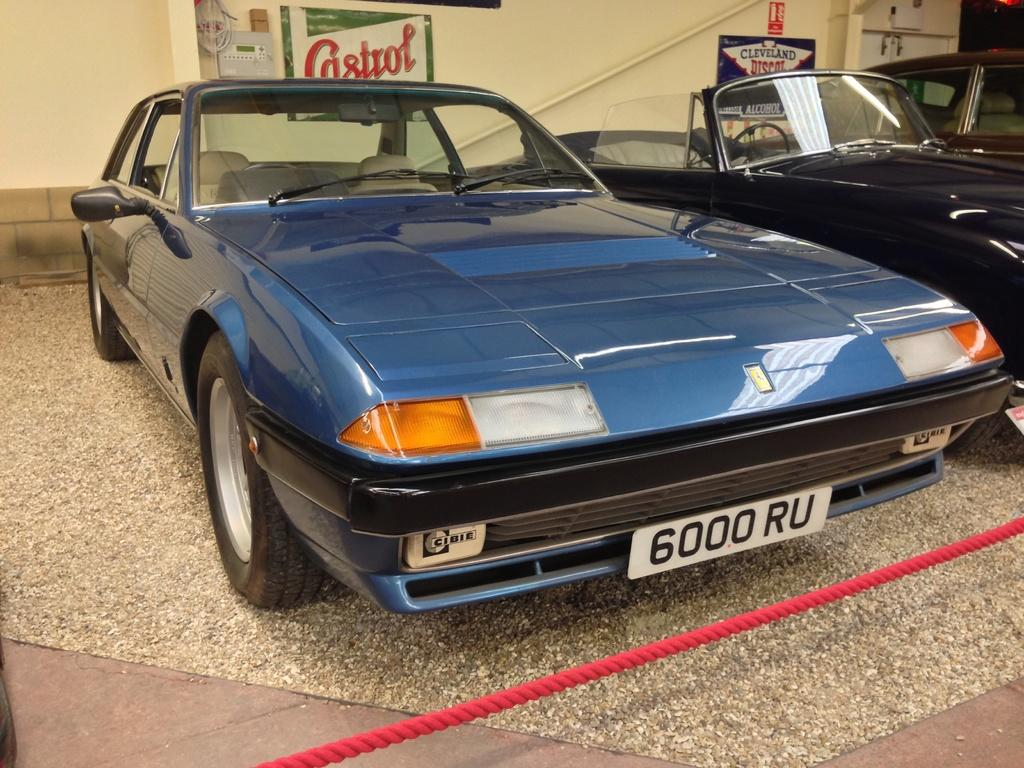What color is the car that is the main subject of the image? There is a blue car in the image. Where is the blue car located? The blue car is parked in a showroom. What other car can be seen in the image? There is a black car in the image. How are the blue and black cars positioned in relation to each other? The black car is parked beside the blue car. What additional detail can be observed in the image? There is a red rope visible in the image. What type of action is the farmer performing with the fan in the image? There is no farmer, fan, or action involving a fan present in the image. 